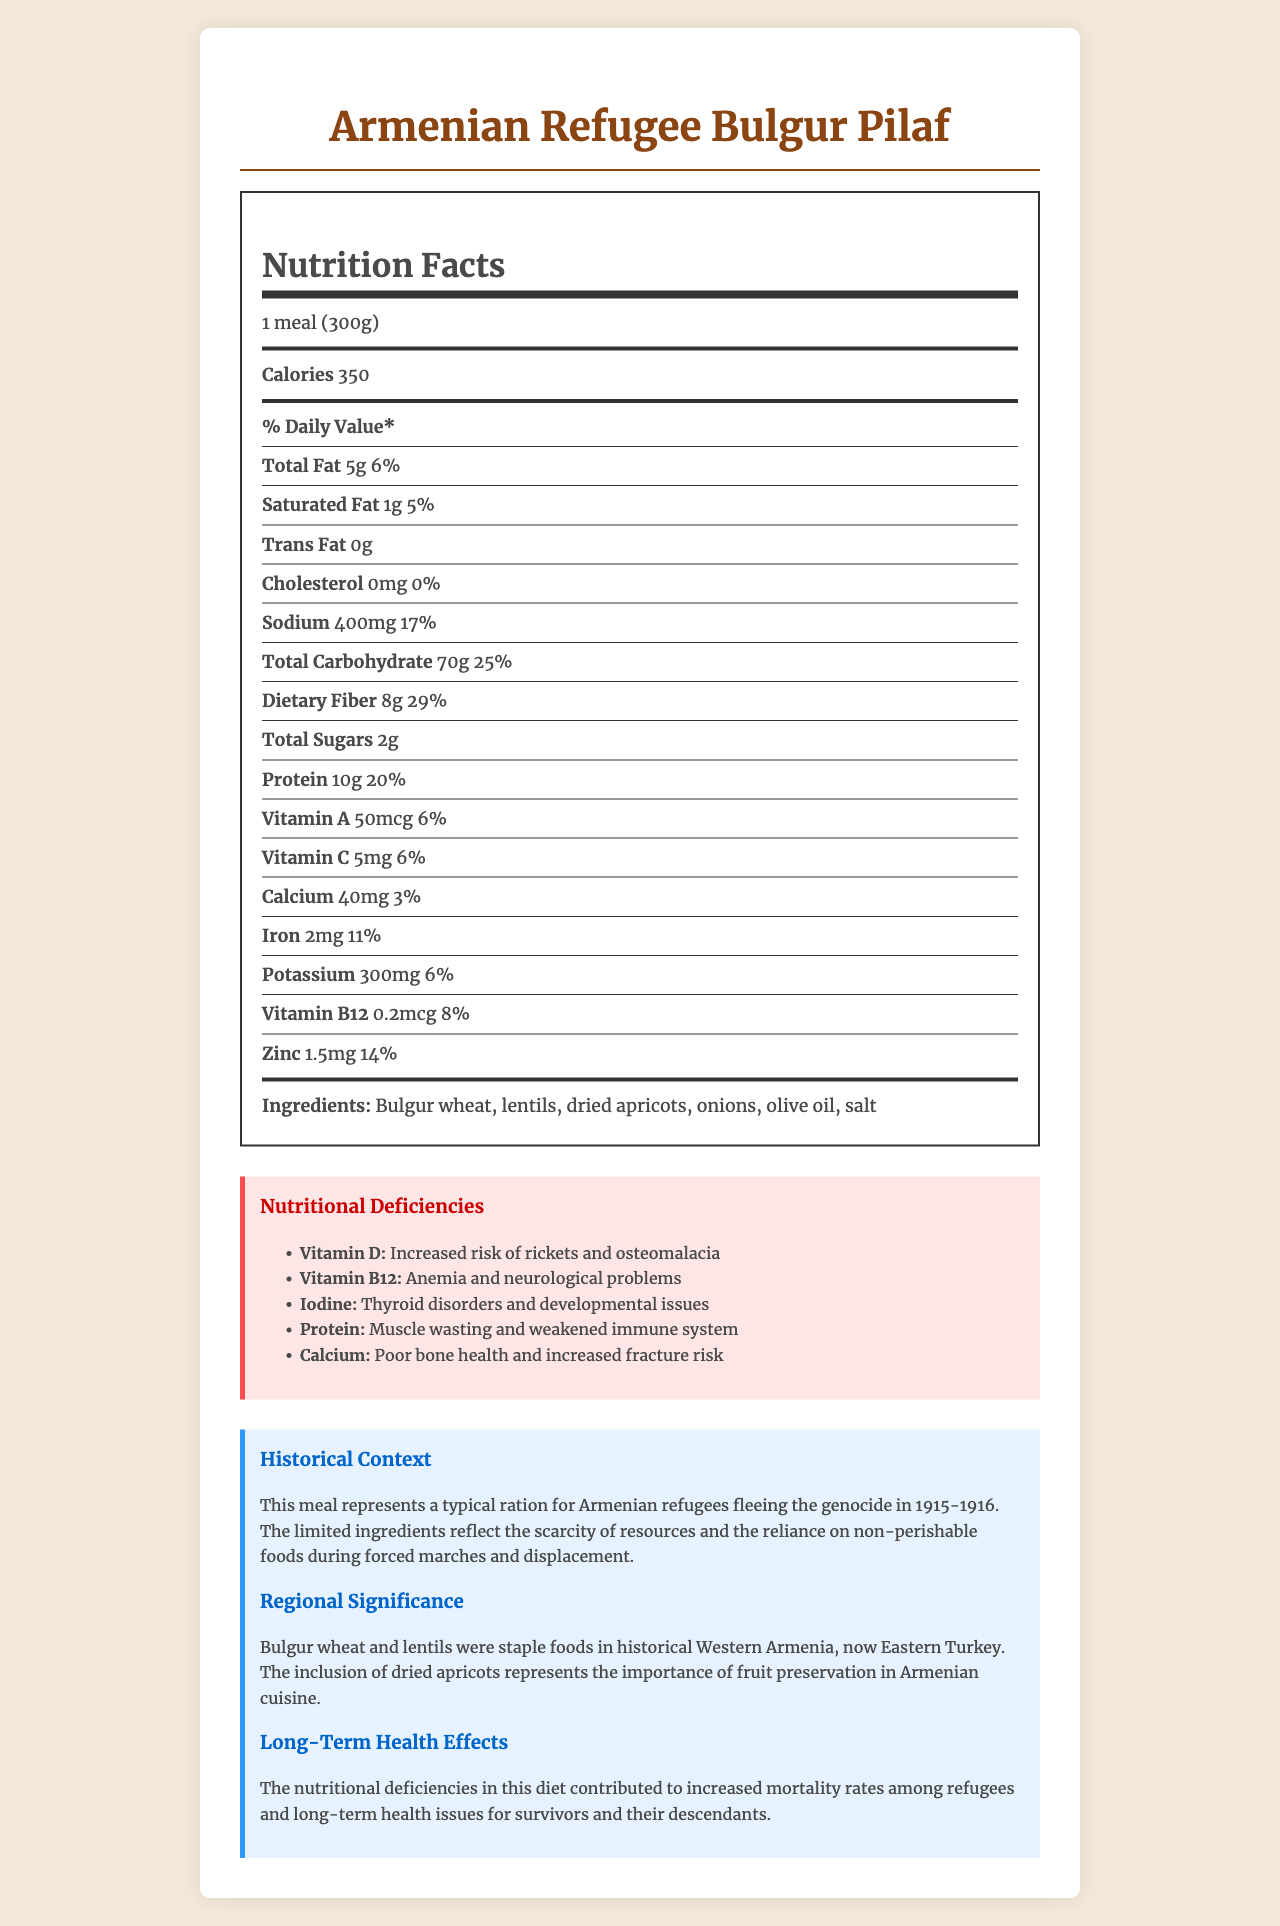What is the serving size of the meal? The serving size is explicitly mentioned at the beginning of the nutrition facts label.
Answer: 1 meal (300g) How many calories does the meal contain? The calorie count per serving is listed right below the serving size.
Answer: 350 What is the amount of protein in this meal? The amount of protein is listed in the nutrients section of the nutrition facts label.
Answer: 10g What is one of the main ingredients in the meal? The ingredients list includes Bulgur wheat, lentils, dried apricots, onions, olive oil, and salt.
Answer: Bulgur wheat Which nutrient has the highest daily value percentage? A. Total Fat B. Dietary Fiber C. Sodium D. Iron Dietary Fiber has a daily value of 29%, which is the highest among the listed nutrients.
Answer: B. Dietary Fiber Which nutritional deficiency is associated with muscle wasting? A. Vitamin D B. Protein C. Calcium D. Iodine The nutritional deficiencies section states that a deficiency in protein can lead to muscle wasting.
Answer: B. Protein Is Vitamin C adequately provided in this meal? The daily value percentage of Vitamin C is only 6%, indicating that it is not adequately provided.
Answer: No Summarize the main idea of the document. The document outlines the components and nutritional values of the meal, explains the historical and regional context, and highlights the health impacts of the nutritional deficiencies faced by refugees.
Answer: The document provides nutritional information about a typical meal (Armenian Refugee Bulgur Pilaf) consumed by Armenian refugees during the genocide, detailing the nutrients, ingredients, historical context, regional significance, and the long-term health effects due to nutritional deficiencies. What is the historical context of the meal? The historical context section of the document explains this meal's significance during the Armenian genocide.
Answer: This meal represents a typical ration for Armenian refugees fleeing the genocide in 1915-1916, reflecting the scarcity of resources and reliance on non-perishable foods during displacement. What is the potential impact of a deficiency in Vitamin B12 mentioned in the document? The nutritional deficiencies section lists anemia and neurological problems as impacts of a deficiency in Vitamin B12.
Answer: Anemia and neurological problems How much calcium is in the meal? The amount of calcium is listed under the nutrients in the nutrition facts label.
Answer: 40mg What are the long-term health effects mentioned in the document? The long-term health effects section details the impact of the nutritional deficiencies on mortality rates and survivor health.
Answer: Increased mortality rates among refugees and long-term health issues for survivors and their descendants How much sodium does the meal contain? The sodium content is listed in the nutrients section of the nutrition facts label.
Answer: 400mg What is the primary grain ingredient in the meal? The ingredient list specifies bulgur wheat as the primary grain used in the meal.
Answer: Bulgur wheat What is the impact of a deficiency in Iodine according to the document? The nutritional deficiencies section notes thyroid disorders and developmental issues as impacts of iodine deficiency.
Answer: Thyroid disorders and developmental issues What percentage of the daily value of Iron does the meal provide? The daily value percentage for Iron is listed in the nutrients section as 11%.
Answer: 11% What is the purpose of the ingredients like dried apricots in the meal? The regional significance section mentions that dried apricots represent the importance of fruit preservation in Armenian cuisine.
Answer: Fruit preservation Which nutrient has a daily value percentage of 20% in the meal? The nutrients section lists protein as having a daily value of 20%.
Answer: Protein How does the meal reflect the regional significance of historical Western Armenia? The regional significance section explains how these ingredients were staple foods and highlights the importance of fruit preservation in the region.
Answer: The inclusion of staple foods like bulgur wheat and lentils and preserved fruits like dried apricots. What was the daily value percentage for Vitamin D in the meal? The document does not provide information on the daily value percentage for Vitamin D, listing it only under nutritional deficiencies.
Answer: Cannot be determined 